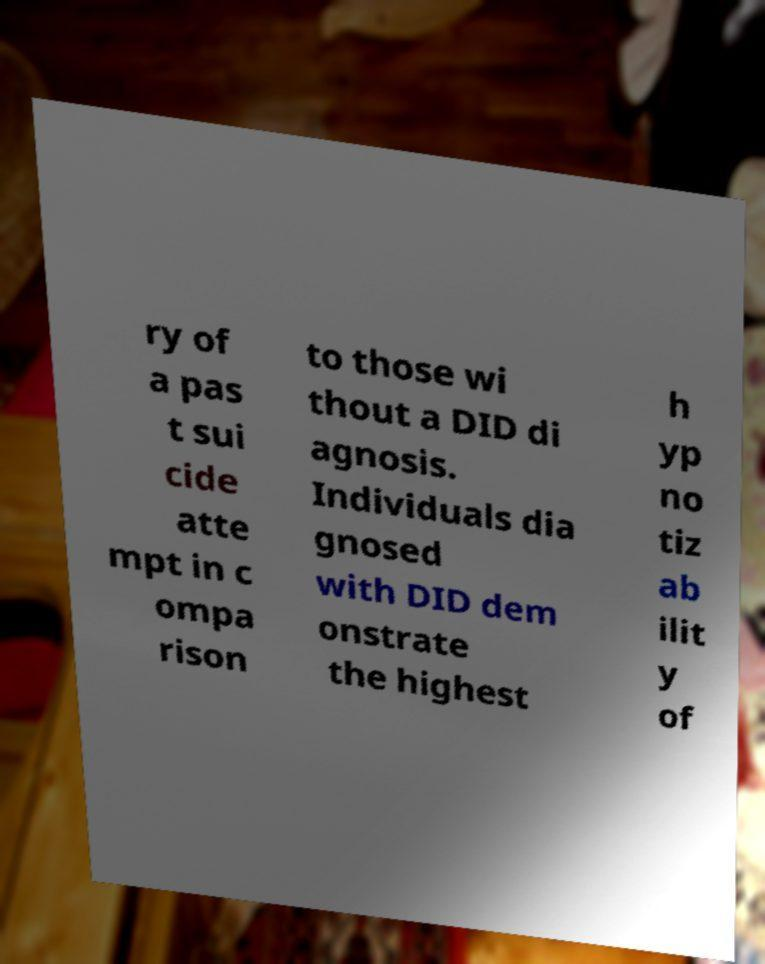For documentation purposes, I need the text within this image transcribed. Could you provide that? ry of a pas t sui cide atte mpt in c ompa rison to those wi thout a DID di agnosis. Individuals dia gnosed with DID dem onstrate the highest h yp no tiz ab ilit y of 